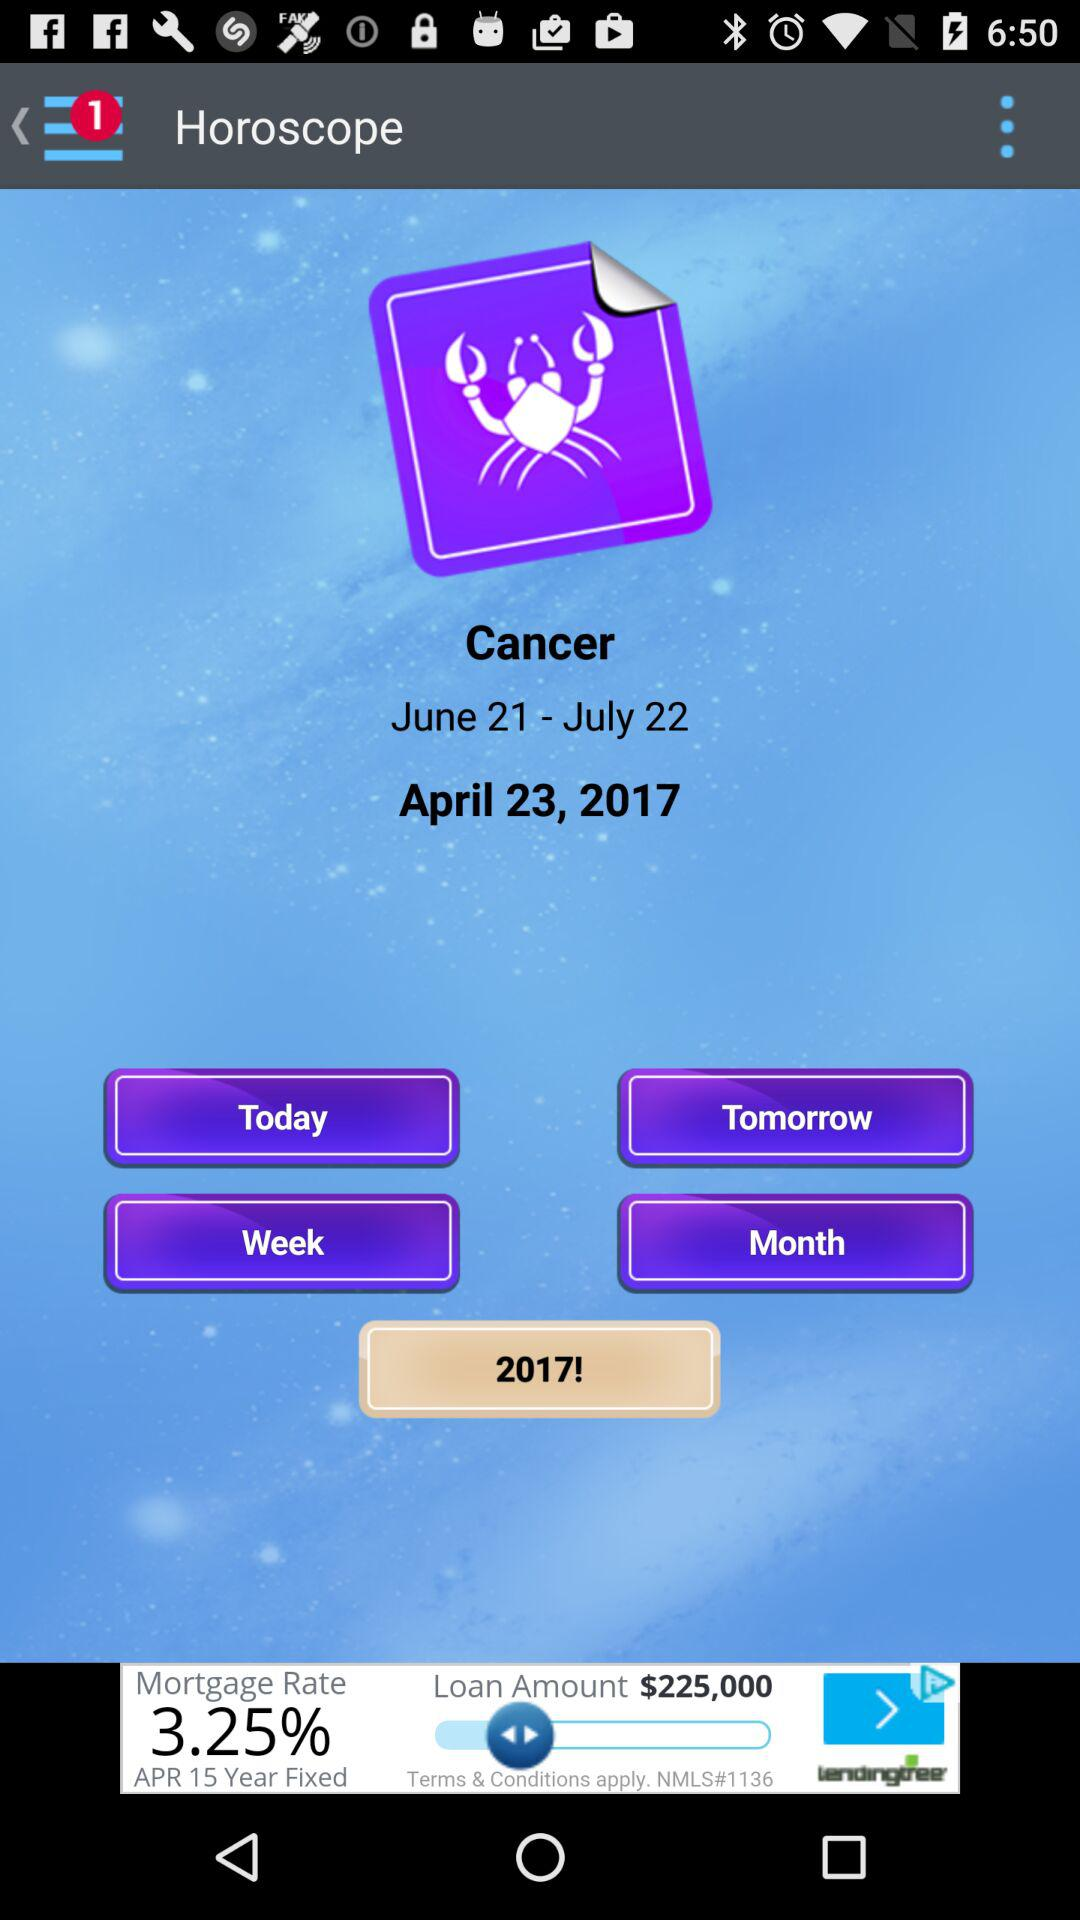What is the mentioned date? The mentioned date is April 23, 2017. 